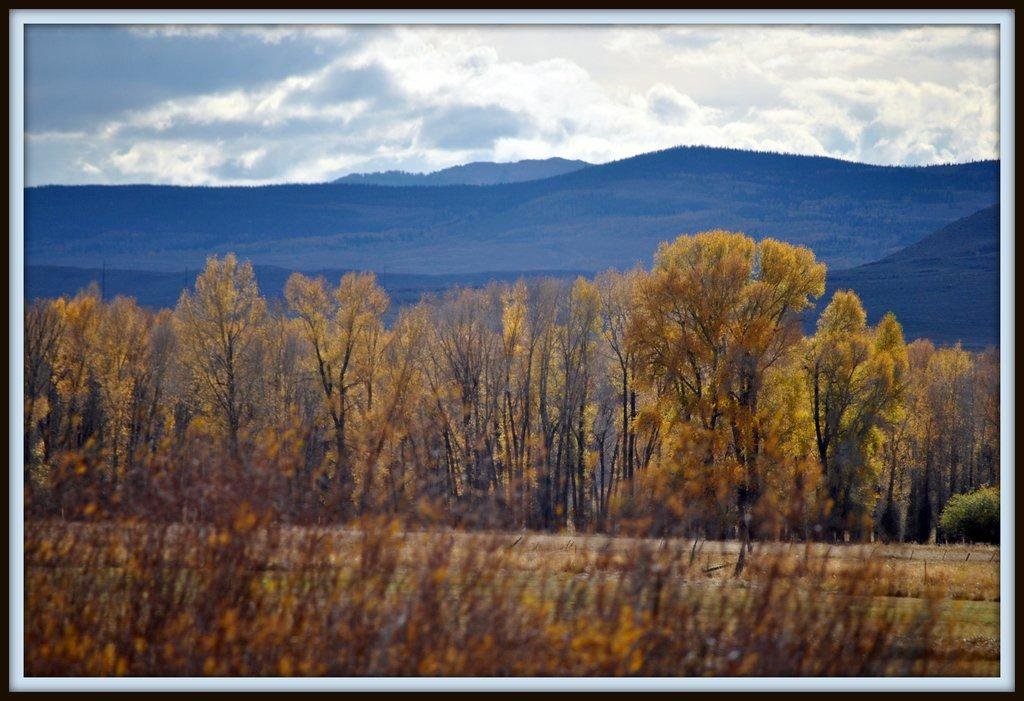What type of object is the image depicting? The image is a photo frame. What natural elements can be seen in the photo frame? There are trees and hills visible in the image. What part of the natural environment is visible in the photo frame? The sky is visible in the image. How would you describe the sky in the photo frame? The sky is cloudy in the image. What note is being played by the trees in the image? There are no musical notes or instruments present in the image; it features trees, hills, and a cloudy sky. 